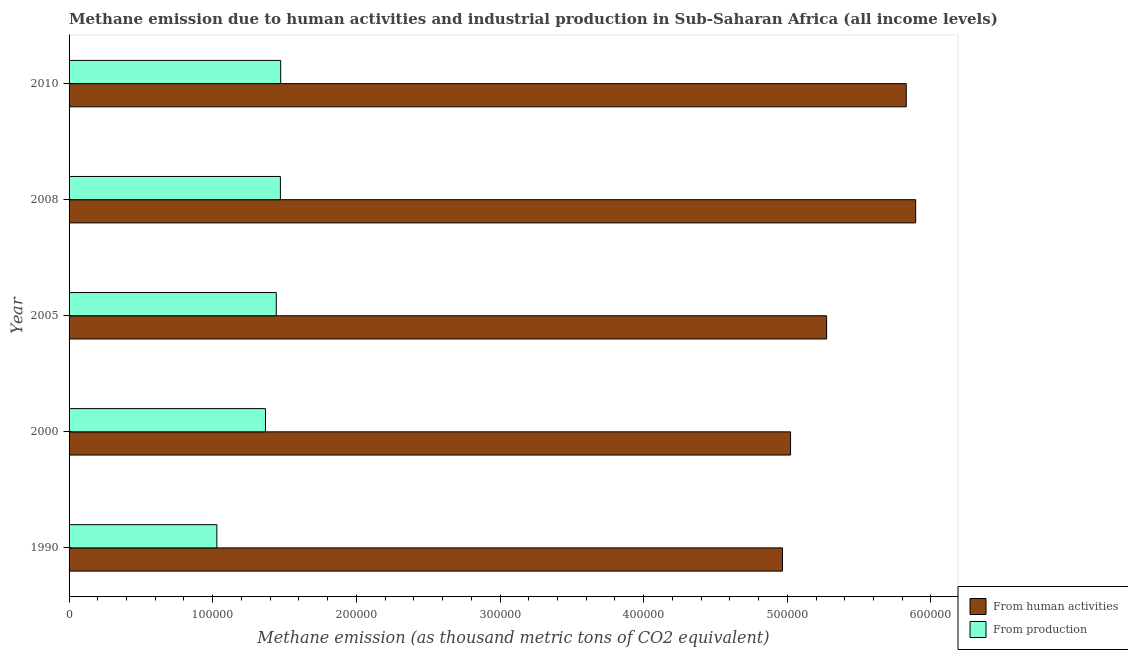How many different coloured bars are there?
Keep it short and to the point. 2. How many groups of bars are there?
Provide a succinct answer. 5. Are the number of bars per tick equal to the number of legend labels?
Offer a very short reply. Yes. What is the amount of emissions from human activities in 2010?
Make the answer very short. 5.83e+05. Across all years, what is the maximum amount of emissions from human activities?
Provide a succinct answer. 5.89e+05. Across all years, what is the minimum amount of emissions from human activities?
Provide a short and direct response. 4.97e+05. What is the total amount of emissions from human activities in the graph?
Your response must be concise. 2.70e+06. What is the difference between the amount of emissions from human activities in 2000 and that in 2005?
Give a very brief answer. -2.51e+04. What is the difference between the amount of emissions generated from industries in 2005 and the amount of emissions from human activities in 2010?
Provide a succinct answer. -4.39e+05. What is the average amount of emissions generated from industries per year?
Your response must be concise. 1.36e+05. In the year 2010, what is the difference between the amount of emissions generated from industries and amount of emissions from human activities?
Offer a terse response. -4.35e+05. What is the ratio of the amount of emissions from human activities in 2008 to that in 2010?
Offer a very short reply. 1.01. Is the amount of emissions from human activities in 2008 less than that in 2010?
Give a very brief answer. No. Is the difference between the amount of emissions generated from industries in 2000 and 2008 greater than the difference between the amount of emissions from human activities in 2000 and 2008?
Your answer should be very brief. Yes. What is the difference between the highest and the second highest amount of emissions generated from industries?
Your answer should be compact. 192.3. What is the difference between the highest and the lowest amount of emissions from human activities?
Keep it short and to the point. 9.27e+04. In how many years, is the amount of emissions from human activities greater than the average amount of emissions from human activities taken over all years?
Ensure brevity in your answer.  2. Is the sum of the amount of emissions generated from industries in 1990 and 2005 greater than the maximum amount of emissions from human activities across all years?
Keep it short and to the point. No. What does the 1st bar from the top in 1990 represents?
Make the answer very short. From production. What does the 2nd bar from the bottom in 1990 represents?
Offer a very short reply. From production. Are all the bars in the graph horizontal?
Offer a very short reply. Yes. How many years are there in the graph?
Give a very brief answer. 5. What is the difference between two consecutive major ticks on the X-axis?
Ensure brevity in your answer.  1.00e+05. Are the values on the major ticks of X-axis written in scientific E-notation?
Provide a short and direct response. No. Where does the legend appear in the graph?
Your answer should be compact. Bottom right. How many legend labels are there?
Offer a terse response. 2. How are the legend labels stacked?
Ensure brevity in your answer.  Vertical. What is the title of the graph?
Provide a succinct answer. Methane emission due to human activities and industrial production in Sub-Saharan Africa (all income levels). What is the label or title of the X-axis?
Your answer should be compact. Methane emission (as thousand metric tons of CO2 equivalent). What is the Methane emission (as thousand metric tons of CO2 equivalent) in From human activities in 1990?
Ensure brevity in your answer.  4.97e+05. What is the Methane emission (as thousand metric tons of CO2 equivalent) of From production in 1990?
Provide a succinct answer. 1.03e+05. What is the Methane emission (as thousand metric tons of CO2 equivalent) in From human activities in 2000?
Your answer should be compact. 5.02e+05. What is the Methane emission (as thousand metric tons of CO2 equivalent) of From production in 2000?
Your response must be concise. 1.37e+05. What is the Methane emission (as thousand metric tons of CO2 equivalent) in From human activities in 2005?
Make the answer very short. 5.27e+05. What is the Methane emission (as thousand metric tons of CO2 equivalent) in From production in 2005?
Provide a short and direct response. 1.44e+05. What is the Methane emission (as thousand metric tons of CO2 equivalent) in From human activities in 2008?
Keep it short and to the point. 5.89e+05. What is the Methane emission (as thousand metric tons of CO2 equivalent) in From production in 2008?
Your answer should be compact. 1.47e+05. What is the Methane emission (as thousand metric tons of CO2 equivalent) in From human activities in 2010?
Make the answer very short. 5.83e+05. What is the Methane emission (as thousand metric tons of CO2 equivalent) in From production in 2010?
Your answer should be very brief. 1.47e+05. Across all years, what is the maximum Methane emission (as thousand metric tons of CO2 equivalent) of From human activities?
Provide a succinct answer. 5.89e+05. Across all years, what is the maximum Methane emission (as thousand metric tons of CO2 equivalent) in From production?
Offer a very short reply. 1.47e+05. Across all years, what is the minimum Methane emission (as thousand metric tons of CO2 equivalent) in From human activities?
Provide a short and direct response. 4.97e+05. Across all years, what is the minimum Methane emission (as thousand metric tons of CO2 equivalent) of From production?
Offer a terse response. 1.03e+05. What is the total Methane emission (as thousand metric tons of CO2 equivalent) of From human activities in the graph?
Your answer should be very brief. 2.70e+06. What is the total Methane emission (as thousand metric tons of CO2 equivalent) of From production in the graph?
Provide a succinct answer. 6.78e+05. What is the difference between the Methane emission (as thousand metric tons of CO2 equivalent) of From human activities in 1990 and that in 2000?
Offer a terse response. -5608.2. What is the difference between the Methane emission (as thousand metric tons of CO2 equivalent) in From production in 1990 and that in 2000?
Ensure brevity in your answer.  -3.38e+04. What is the difference between the Methane emission (as thousand metric tons of CO2 equivalent) in From human activities in 1990 and that in 2005?
Make the answer very short. -3.07e+04. What is the difference between the Methane emission (as thousand metric tons of CO2 equivalent) in From production in 1990 and that in 2005?
Make the answer very short. -4.14e+04. What is the difference between the Methane emission (as thousand metric tons of CO2 equivalent) of From human activities in 1990 and that in 2008?
Your answer should be compact. -9.27e+04. What is the difference between the Methane emission (as thousand metric tons of CO2 equivalent) of From production in 1990 and that in 2008?
Offer a terse response. -4.42e+04. What is the difference between the Methane emission (as thousand metric tons of CO2 equivalent) in From human activities in 1990 and that in 2010?
Your answer should be compact. -8.61e+04. What is the difference between the Methane emission (as thousand metric tons of CO2 equivalent) in From production in 1990 and that in 2010?
Offer a terse response. -4.44e+04. What is the difference between the Methane emission (as thousand metric tons of CO2 equivalent) of From human activities in 2000 and that in 2005?
Provide a succinct answer. -2.51e+04. What is the difference between the Methane emission (as thousand metric tons of CO2 equivalent) in From production in 2000 and that in 2005?
Your answer should be very brief. -7528.2. What is the difference between the Methane emission (as thousand metric tons of CO2 equivalent) of From human activities in 2000 and that in 2008?
Offer a very short reply. -8.71e+04. What is the difference between the Methane emission (as thousand metric tons of CO2 equivalent) of From production in 2000 and that in 2008?
Give a very brief answer. -1.04e+04. What is the difference between the Methane emission (as thousand metric tons of CO2 equivalent) of From human activities in 2000 and that in 2010?
Provide a short and direct response. -8.05e+04. What is the difference between the Methane emission (as thousand metric tons of CO2 equivalent) of From production in 2000 and that in 2010?
Offer a very short reply. -1.06e+04. What is the difference between the Methane emission (as thousand metric tons of CO2 equivalent) of From human activities in 2005 and that in 2008?
Keep it short and to the point. -6.20e+04. What is the difference between the Methane emission (as thousand metric tons of CO2 equivalent) in From production in 2005 and that in 2008?
Your answer should be compact. -2859.6. What is the difference between the Methane emission (as thousand metric tons of CO2 equivalent) in From human activities in 2005 and that in 2010?
Offer a very short reply. -5.54e+04. What is the difference between the Methane emission (as thousand metric tons of CO2 equivalent) in From production in 2005 and that in 2010?
Offer a terse response. -3051.9. What is the difference between the Methane emission (as thousand metric tons of CO2 equivalent) of From human activities in 2008 and that in 2010?
Ensure brevity in your answer.  6576.5. What is the difference between the Methane emission (as thousand metric tons of CO2 equivalent) in From production in 2008 and that in 2010?
Provide a short and direct response. -192.3. What is the difference between the Methane emission (as thousand metric tons of CO2 equivalent) in From human activities in 1990 and the Methane emission (as thousand metric tons of CO2 equivalent) in From production in 2000?
Offer a very short reply. 3.60e+05. What is the difference between the Methane emission (as thousand metric tons of CO2 equivalent) of From human activities in 1990 and the Methane emission (as thousand metric tons of CO2 equivalent) of From production in 2005?
Give a very brief answer. 3.52e+05. What is the difference between the Methane emission (as thousand metric tons of CO2 equivalent) in From human activities in 1990 and the Methane emission (as thousand metric tons of CO2 equivalent) in From production in 2008?
Your answer should be compact. 3.50e+05. What is the difference between the Methane emission (as thousand metric tons of CO2 equivalent) of From human activities in 1990 and the Methane emission (as thousand metric tons of CO2 equivalent) of From production in 2010?
Offer a terse response. 3.49e+05. What is the difference between the Methane emission (as thousand metric tons of CO2 equivalent) in From human activities in 2000 and the Methane emission (as thousand metric tons of CO2 equivalent) in From production in 2005?
Ensure brevity in your answer.  3.58e+05. What is the difference between the Methane emission (as thousand metric tons of CO2 equivalent) of From human activities in 2000 and the Methane emission (as thousand metric tons of CO2 equivalent) of From production in 2008?
Your answer should be compact. 3.55e+05. What is the difference between the Methane emission (as thousand metric tons of CO2 equivalent) in From human activities in 2000 and the Methane emission (as thousand metric tons of CO2 equivalent) in From production in 2010?
Your response must be concise. 3.55e+05. What is the difference between the Methane emission (as thousand metric tons of CO2 equivalent) of From human activities in 2005 and the Methane emission (as thousand metric tons of CO2 equivalent) of From production in 2008?
Your answer should be compact. 3.80e+05. What is the difference between the Methane emission (as thousand metric tons of CO2 equivalent) of From human activities in 2005 and the Methane emission (as thousand metric tons of CO2 equivalent) of From production in 2010?
Make the answer very short. 3.80e+05. What is the difference between the Methane emission (as thousand metric tons of CO2 equivalent) in From human activities in 2008 and the Methane emission (as thousand metric tons of CO2 equivalent) in From production in 2010?
Provide a succinct answer. 4.42e+05. What is the average Methane emission (as thousand metric tons of CO2 equivalent) of From human activities per year?
Your response must be concise. 5.40e+05. What is the average Methane emission (as thousand metric tons of CO2 equivalent) of From production per year?
Provide a succinct answer. 1.36e+05. In the year 1990, what is the difference between the Methane emission (as thousand metric tons of CO2 equivalent) in From human activities and Methane emission (as thousand metric tons of CO2 equivalent) in From production?
Keep it short and to the point. 3.94e+05. In the year 2000, what is the difference between the Methane emission (as thousand metric tons of CO2 equivalent) in From human activities and Methane emission (as thousand metric tons of CO2 equivalent) in From production?
Give a very brief answer. 3.66e+05. In the year 2005, what is the difference between the Methane emission (as thousand metric tons of CO2 equivalent) of From human activities and Methane emission (as thousand metric tons of CO2 equivalent) of From production?
Make the answer very short. 3.83e+05. In the year 2008, what is the difference between the Methane emission (as thousand metric tons of CO2 equivalent) in From human activities and Methane emission (as thousand metric tons of CO2 equivalent) in From production?
Ensure brevity in your answer.  4.42e+05. In the year 2010, what is the difference between the Methane emission (as thousand metric tons of CO2 equivalent) in From human activities and Methane emission (as thousand metric tons of CO2 equivalent) in From production?
Your answer should be very brief. 4.35e+05. What is the ratio of the Methane emission (as thousand metric tons of CO2 equivalent) of From human activities in 1990 to that in 2000?
Your answer should be very brief. 0.99. What is the ratio of the Methane emission (as thousand metric tons of CO2 equivalent) in From production in 1990 to that in 2000?
Provide a short and direct response. 0.75. What is the ratio of the Methane emission (as thousand metric tons of CO2 equivalent) of From human activities in 1990 to that in 2005?
Keep it short and to the point. 0.94. What is the ratio of the Methane emission (as thousand metric tons of CO2 equivalent) in From production in 1990 to that in 2005?
Your answer should be very brief. 0.71. What is the ratio of the Methane emission (as thousand metric tons of CO2 equivalent) in From human activities in 1990 to that in 2008?
Ensure brevity in your answer.  0.84. What is the ratio of the Methane emission (as thousand metric tons of CO2 equivalent) of From production in 1990 to that in 2008?
Provide a short and direct response. 0.7. What is the ratio of the Methane emission (as thousand metric tons of CO2 equivalent) in From human activities in 1990 to that in 2010?
Provide a succinct answer. 0.85. What is the ratio of the Methane emission (as thousand metric tons of CO2 equivalent) in From production in 1990 to that in 2010?
Your answer should be very brief. 0.7. What is the ratio of the Methane emission (as thousand metric tons of CO2 equivalent) in From production in 2000 to that in 2005?
Give a very brief answer. 0.95. What is the ratio of the Methane emission (as thousand metric tons of CO2 equivalent) in From human activities in 2000 to that in 2008?
Provide a succinct answer. 0.85. What is the ratio of the Methane emission (as thousand metric tons of CO2 equivalent) in From production in 2000 to that in 2008?
Ensure brevity in your answer.  0.93. What is the ratio of the Methane emission (as thousand metric tons of CO2 equivalent) in From human activities in 2000 to that in 2010?
Your answer should be very brief. 0.86. What is the ratio of the Methane emission (as thousand metric tons of CO2 equivalent) of From production in 2000 to that in 2010?
Provide a succinct answer. 0.93. What is the ratio of the Methane emission (as thousand metric tons of CO2 equivalent) of From human activities in 2005 to that in 2008?
Give a very brief answer. 0.89. What is the ratio of the Methane emission (as thousand metric tons of CO2 equivalent) of From production in 2005 to that in 2008?
Make the answer very short. 0.98. What is the ratio of the Methane emission (as thousand metric tons of CO2 equivalent) in From human activities in 2005 to that in 2010?
Keep it short and to the point. 0.9. What is the ratio of the Methane emission (as thousand metric tons of CO2 equivalent) in From production in 2005 to that in 2010?
Your response must be concise. 0.98. What is the ratio of the Methane emission (as thousand metric tons of CO2 equivalent) in From human activities in 2008 to that in 2010?
Provide a succinct answer. 1.01. What is the difference between the highest and the second highest Methane emission (as thousand metric tons of CO2 equivalent) in From human activities?
Provide a succinct answer. 6576.5. What is the difference between the highest and the second highest Methane emission (as thousand metric tons of CO2 equivalent) in From production?
Offer a terse response. 192.3. What is the difference between the highest and the lowest Methane emission (as thousand metric tons of CO2 equivalent) in From human activities?
Your answer should be compact. 9.27e+04. What is the difference between the highest and the lowest Methane emission (as thousand metric tons of CO2 equivalent) in From production?
Provide a short and direct response. 4.44e+04. 